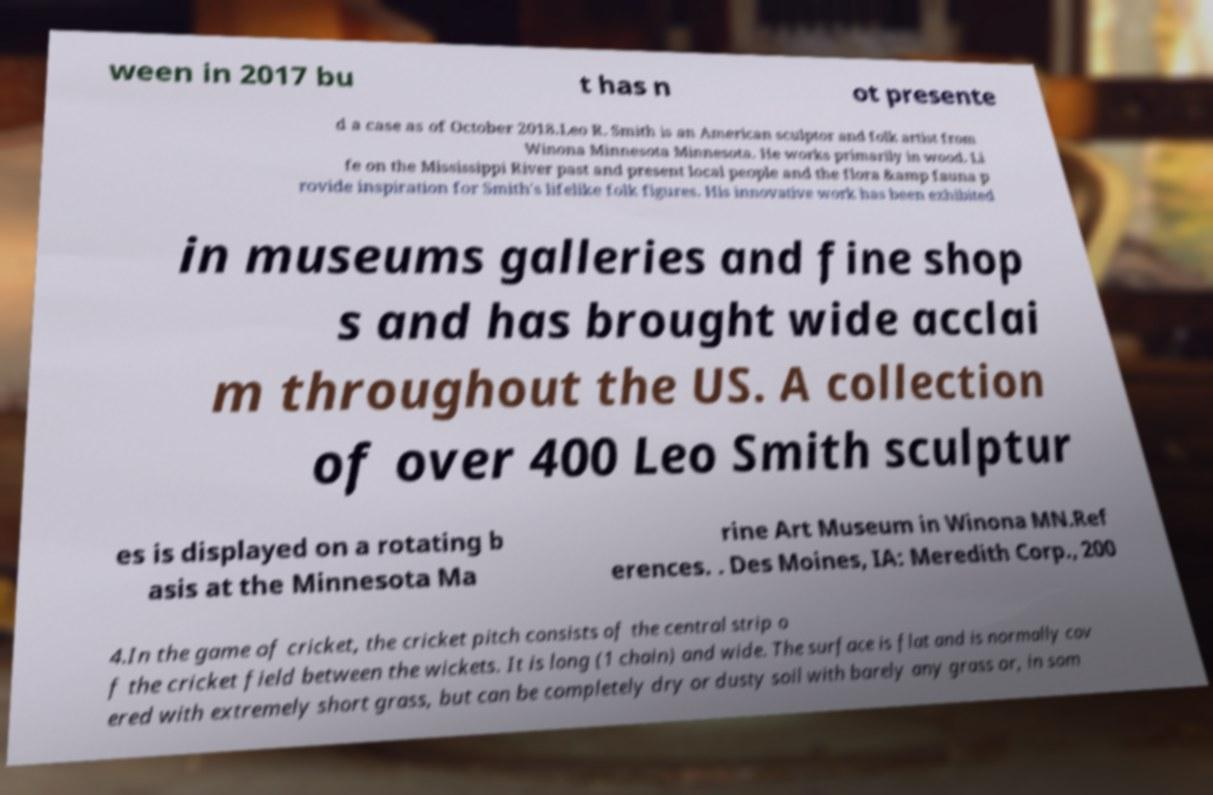Can you accurately transcribe the text from the provided image for me? ween in 2017 bu t has n ot presente d a case as of October 2018.Leo R. Smith is an American sculptor and folk artist from Winona Minnesota Minnesota. He works primarily in wood. Li fe on the Mississippi River past and present local people and the flora &amp fauna p rovide inspiration for Smith's lifelike folk figures. His innovative work has been exhibited in museums galleries and fine shop s and has brought wide acclai m throughout the US. A collection of over 400 Leo Smith sculptur es is displayed on a rotating b asis at the Minnesota Ma rine Art Museum in Winona MN.Ref erences. . Des Moines, IA: Meredith Corp., 200 4.In the game of cricket, the cricket pitch consists of the central strip o f the cricket field between the wickets. It is long (1 chain) and wide. The surface is flat and is normally cov ered with extremely short grass, but can be completely dry or dusty soil with barely any grass or, in som 